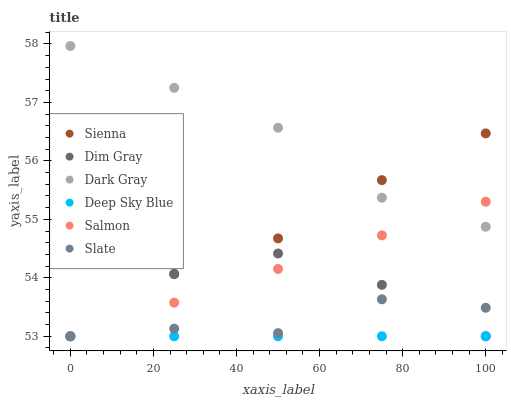Does Deep Sky Blue have the minimum area under the curve?
Answer yes or no. Yes. Does Dark Gray have the maximum area under the curve?
Answer yes or no. Yes. Does Dim Gray have the minimum area under the curve?
Answer yes or no. No. Does Dim Gray have the maximum area under the curve?
Answer yes or no. No. Is Deep Sky Blue the smoothest?
Answer yes or no. Yes. Is Dim Gray the roughest?
Answer yes or no. Yes. Is Slate the smoothest?
Answer yes or no. No. Is Slate the roughest?
Answer yes or no. No. Does Dim Gray have the lowest value?
Answer yes or no. Yes. Does Dark Gray have the highest value?
Answer yes or no. Yes. Does Dim Gray have the highest value?
Answer yes or no. No. Is Slate less than Dark Gray?
Answer yes or no. Yes. Is Dark Gray greater than Slate?
Answer yes or no. Yes. Does Dim Gray intersect Sienna?
Answer yes or no. Yes. Is Dim Gray less than Sienna?
Answer yes or no. No. Is Dim Gray greater than Sienna?
Answer yes or no. No. Does Slate intersect Dark Gray?
Answer yes or no. No. 